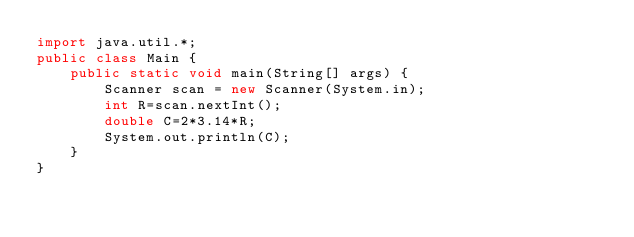<code> <loc_0><loc_0><loc_500><loc_500><_Java_>import java.util.*;
public class Main {
    public static void main(String[] args) {
        Scanner scan = new Scanner(System.in);
        int R=scan.nextInt();
        double C=2*3.14*R;
        System.out.println(C);
    }
}</code> 